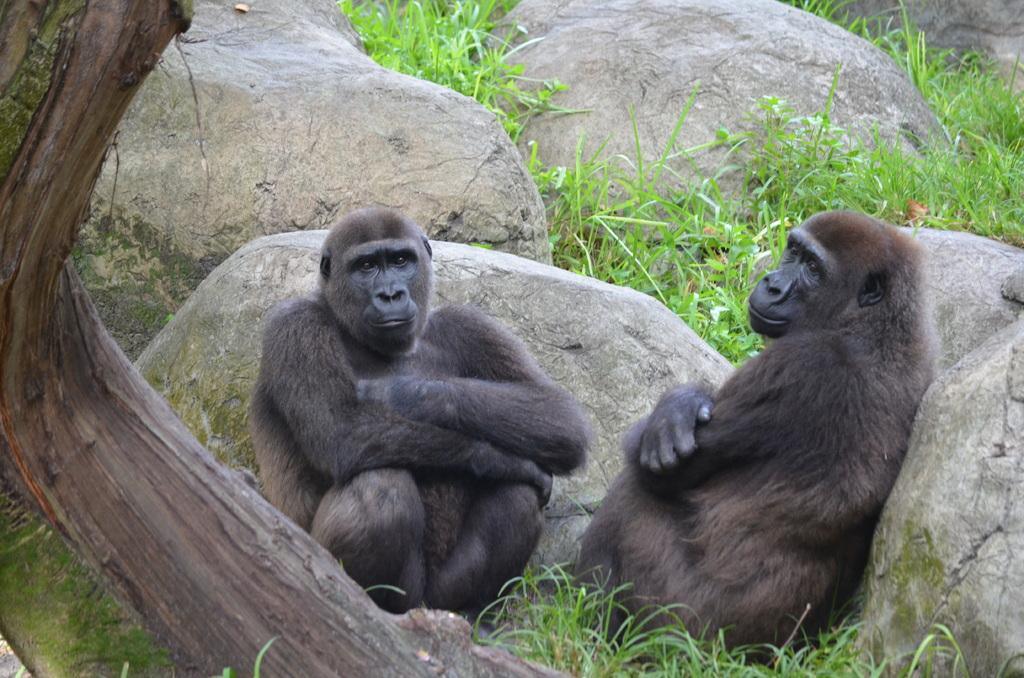What is located in the center of the image? There are animals in the center of the image. What are the animals doing in the image? The animals are sitting on the ground. What type of surface are the animals sitting on? There is grass on the ground. What other objects can be seen in the image? There are stones visible in the image. What order did the animals follow to reach the island in the image? There is no island present in the image, and the animals are not following any order to reach a specific location. 